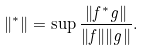Convert formula to latex. <formula><loc_0><loc_0><loc_500><loc_500>\| ^ { * } \| = \sup \frac { \| f ^ { * } g \| } { \| f \| \| g \| } .</formula> 